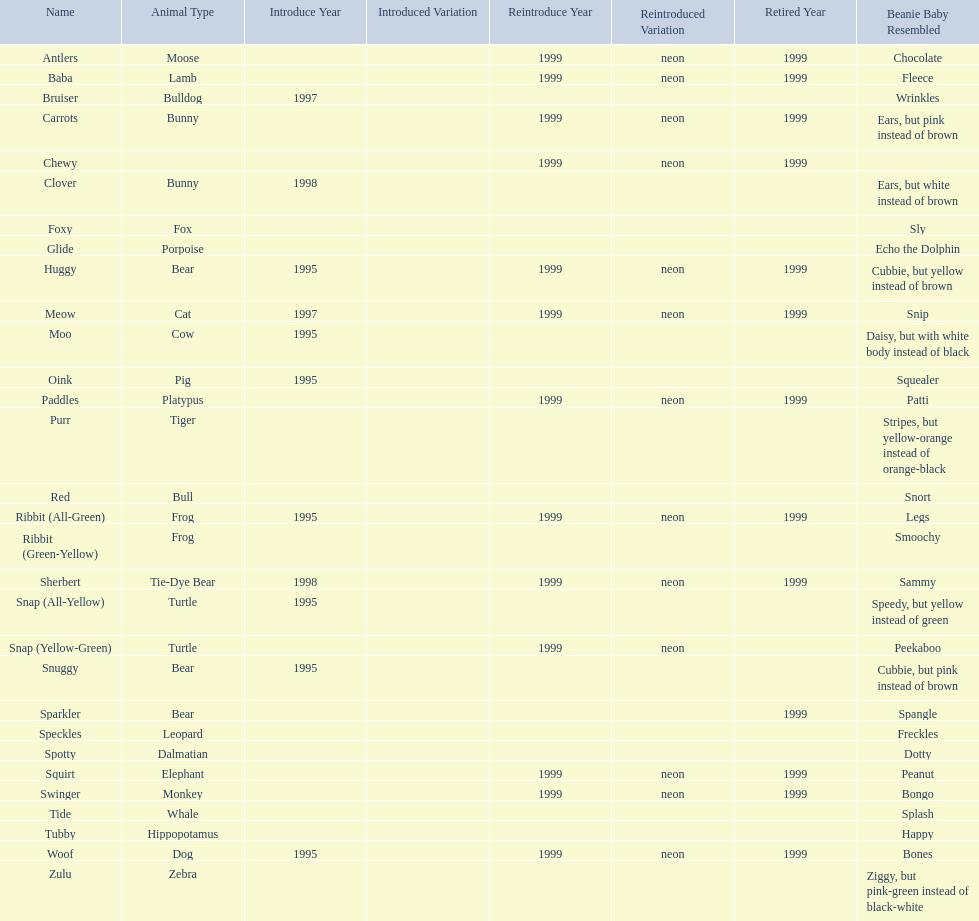How many total pillow pals were both reintroduced and retired in 1999? 12. 